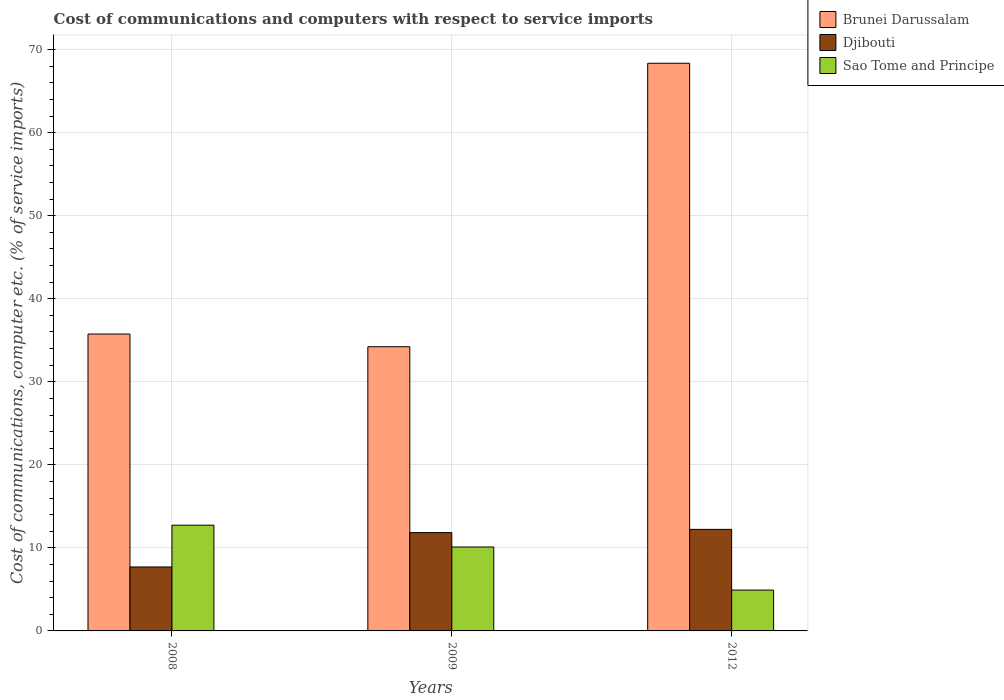How many different coloured bars are there?
Ensure brevity in your answer.  3. Are the number of bars per tick equal to the number of legend labels?
Give a very brief answer. Yes. How many bars are there on the 3rd tick from the left?
Your answer should be compact. 3. How many bars are there on the 3rd tick from the right?
Offer a very short reply. 3. What is the label of the 1st group of bars from the left?
Offer a terse response. 2008. In how many cases, is the number of bars for a given year not equal to the number of legend labels?
Give a very brief answer. 0. What is the cost of communications and computers in Djibouti in 2008?
Give a very brief answer. 7.7. Across all years, what is the maximum cost of communications and computers in Djibouti?
Your response must be concise. 12.23. Across all years, what is the minimum cost of communications and computers in Djibouti?
Offer a terse response. 7.7. In which year was the cost of communications and computers in Sao Tome and Principe maximum?
Provide a succinct answer. 2008. What is the total cost of communications and computers in Djibouti in the graph?
Keep it short and to the point. 31.77. What is the difference between the cost of communications and computers in Brunei Darussalam in 2009 and that in 2012?
Your answer should be very brief. -34.14. What is the difference between the cost of communications and computers in Sao Tome and Principe in 2009 and the cost of communications and computers in Brunei Darussalam in 2012?
Provide a short and direct response. -58.26. What is the average cost of communications and computers in Sao Tome and Principe per year?
Ensure brevity in your answer.  9.25. In the year 2009, what is the difference between the cost of communications and computers in Sao Tome and Principe and cost of communications and computers in Brunei Darussalam?
Make the answer very short. -24.12. In how many years, is the cost of communications and computers in Sao Tome and Principe greater than 12 %?
Your answer should be very brief. 1. What is the ratio of the cost of communications and computers in Djibouti in 2008 to that in 2009?
Your answer should be compact. 0.65. Is the difference between the cost of communications and computers in Sao Tome and Principe in 2009 and 2012 greater than the difference between the cost of communications and computers in Brunei Darussalam in 2009 and 2012?
Your answer should be compact. Yes. What is the difference between the highest and the second highest cost of communications and computers in Djibouti?
Offer a very short reply. 0.39. What is the difference between the highest and the lowest cost of communications and computers in Brunei Darussalam?
Your answer should be compact. 34.14. What does the 2nd bar from the left in 2009 represents?
Ensure brevity in your answer.  Djibouti. What does the 2nd bar from the right in 2012 represents?
Provide a short and direct response. Djibouti. Is it the case that in every year, the sum of the cost of communications and computers in Sao Tome and Principe and cost of communications and computers in Brunei Darussalam is greater than the cost of communications and computers in Djibouti?
Make the answer very short. Yes. How many bars are there?
Provide a succinct answer. 9. How many years are there in the graph?
Give a very brief answer. 3. Does the graph contain grids?
Make the answer very short. Yes. Where does the legend appear in the graph?
Offer a terse response. Top right. How are the legend labels stacked?
Make the answer very short. Vertical. What is the title of the graph?
Provide a short and direct response. Cost of communications and computers with respect to service imports. What is the label or title of the Y-axis?
Keep it short and to the point. Cost of communications, computer etc. (% of service imports). What is the Cost of communications, computer etc. (% of service imports) in Brunei Darussalam in 2008?
Make the answer very short. 35.76. What is the Cost of communications, computer etc. (% of service imports) in Djibouti in 2008?
Offer a terse response. 7.7. What is the Cost of communications, computer etc. (% of service imports) in Sao Tome and Principe in 2008?
Provide a short and direct response. 12.73. What is the Cost of communications, computer etc. (% of service imports) of Brunei Darussalam in 2009?
Your answer should be very brief. 34.22. What is the Cost of communications, computer etc. (% of service imports) in Djibouti in 2009?
Offer a very short reply. 11.84. What is the Cost of communications, computer etc. (% of service imports) of Sao Tome and Principe in 2009?
Your answer should be very brief. 10.11. What is the Cost of communications, computer etc. (% of service imports) of Brunei Darussalam in 2012?
Provide a succinct answer. 68.36. What is the Cost of communications, computer etc. (% of service imports) in Djibouti in 2012?
Offer a terse response. 12.23. What is the Cost of communications, computer etc. (% of service imports) of Sao Tome and Principe in 2012?
Your answer should be very brief. 4.92. Across all years, what is the maximum Cost of communications, computer etc. (% of service imports) of Brunei Darussalam?
Offer a terse response. 68.36. Across all years, what is the maximum Cost of communications, computer etc. (% of service imports) of Djibouti?
Provide a succinct answer. 12.23. Across all years, what is the maximum Cost of communications, computer etc. (% of service imports) of Sao Tome and Principe?
Ensure brevity in your answer.  12.73. Across all years, what is the minimum Cost of communications, computer etc. (% of service imports) of Brunei Darussalam?
Your answer should be very brief. 34.22. Across all years, what is the minimum Cost of communications, computer etc. (% of service imports) of Djibouti?
Your answer should be compact. 7.7. Across all years, what is the minimum Cost of communications, computer etc. (% of service imports) in Sao Tome and Principe?
Your response must be concise. 4.92. What is the total Cost of communications, computer etc. (% of service imports) of Brunei Darussalam in the graph?
Your answer should be compact. 138.34. What is the total Cost of communications, computer etc. (% of service imports) in Djibouti in the graph?
Offer a terse response. 31.77. What is the total Cost of communications, computer etc. (% of service imports) of Sao Tome and Principe in the graph?
Offer a very short reply. 27.76. What is the difference between the Cost of communications, computer etc. (% of service imports) of Brunei Darussalam in 2008 and that in 2009?
Your answer should be very brief. 1.53. What is the difference between the Cost of communications, computer etc. (% of service imports) in Djibouti in 2008 and that in 2009?
Your answer should be compact. -4.14. What is the difference between the Cost of communications, computer etc. (% of service imports) of Sao Tome and Principe in 2008 and that in 2009?
Make the answer very short. 2.63. What is the difference between the Cost of communications, computer etc. (% of service imports) in Brunei Darussalam in 2008 and that in 2012?
Offer a very short reply. -32.61. What is the difference between the Cost of communications, computer etc. (% of service imports) of Djibouti in 2008 and that in 2012?
Offer a very short reply. -4.53. What is the difference between the Cost of communications, computer etc. (% of service imports) of Sao Tome and Principe in 2008 and that in 2012?
Your answer should be very brief. 7.81. What is the difference between the Cost of communications, computer etc. (% of service imports) of Brunei Darussalam in 2009 and that in 2012?
Your answer should be very brief. -34.14. What is the difference between the Cost of communications, computer etc. (% of service imports) in Djibouti in 2009 and that in 2012?
Your response must be concise. -0.39. What is the difference between the Cost of communications, computer etc. (% of service imports) of Sao Tome and Principe in 2009 and that in 2012?
Your answer should be compact. 5.19. What is the difference between the Cost of communications, computer etc. (% of service imports) of Brunei Darussalam in 2008 and the Cost of communications, computer etc. (% of service imports) of Djibouti in 2009?
Provide a succinct answer. 23.92. What is the difference between the Cost of communications, computer etc. (% of service imports) of Brunei Darussalam in 2008 and the Cost of communications, computer etc. (% of service imports) of Sao Tome and Principe in 2009?
Provide a short and direct response. 25.65. What is the difference between the Cost of communications, computer etc. (% of service imports) in Djibouti in 2008 and the Cost of communications, computer etc. (% of service imports) in Sao Tome and Principe in 2009?
Ensure brevity in your answer.  -2.4. What is the difference between the Cost of communications, computer etc. (% of service imports) in Brunei Darussalam in 2008 and the Cost of communications, computer etc. (% of service imports) in Djibouti in 2012?
Offer a terse response. 23.53. What is the difference between the Cost of communications, computer etc. (% of service imports) in Brunei Darussalam in 2008 and the Cost of communications, computer etc. (% of service imports) in Sao Tome and Principe in 2012?
Give a very brief answer. 30.84. What is the difference between the Cost of communications, computer etc. (% of service imports) in Djibouti in 2008 and the Cost of communications, computer etc. (% of service imports) in Sao Tome and Principe in 2012?
Offer a very short reply. 2.78. What is the difference between the Cost of communications, computer etc. (% of service imports) in Brunei Darussalam in 2009 and the Cost of communications, computer etc. (% of service imports) in Djibouti in 2012?
Keep it short and to the point. 22. What is the difference between the Cost of communications, computer etc. (% of service imports) of Brunei Darussalam in 2009 and the Cost of communications, computer etc. (% of service imports) of Sao Tome and Principe in 2012?
Make the answer very short. 29.31. What is the difference between the Cost of communications, computer etc. (% of service imports) in Djibouti in 2009 and the Cost of communications, computer etc. (% of service imports) in Sao Tome and Principe in 2012?
Provide a short and direct response. 6.92. What is the average Cost of communications, computer etc. (% of service imports) of Brunei Darussalam per year?
Provide a succinct answer. 46.11. What is the average Cost of communications, computer etc. (% of service imports) of Djibouti per year?
Provide a short and direct response. 10.59. What is the average Cost of communications, computer etc. (% of service imports) in Sao Tome and Principe per year?
Make the answer very short. 9.25. In the year 2008, what is the difference between the Cost of communications, computer etc. (% of service imports) in Brunei Darussalam and Cost of communications, computer etc. (% of service imports) in Djibouti?
Offer a very short reply. 28.05. In the year 2008, what is the difference between the Cost of communications, computer etc. (% of service imports) in Brunei Darussalam and Cost of communications, computer etc. (% of service imports) in Sao Tome and Principe?
Offer a very short reply. 23.02. In the year 2008, what is the difference between the Cost of communications, computer etc. (% of service imports) in Djibouti and Cost of communications, computer etc. (% of service imports) in Sao Tome and Principe?
Provide a succinct answer. -5.03. In the year 2009, what is the difference between the Cost of communications, computer etc. (% of service imports) in Brunei Darussalam and Cost of communications, computer etc. (% of service imports) in Djibouti?
Provide a succinct answer. 22.39. In the year 2009, what is the difference between the Cost of communications, computer etc. (% of service imports) in Brunei Darussalam and Cost of communications, computer etc. (% of service imports) in Sao Tome and Principe?
Provide a short and direct response. 24.12. In the year 2009, what is the difference between the Cost of communications, computer etc. (% of service imports) in Djibouti and Cost of communications, computer etc. (% of service imports) in Sao Tome and Principe?
Your response must be concise. 1.73. In the year 2012, what is the difference between the Cost of communications, computer etc. (% of service imports) of Brunei Darussalam and Cost of communications, computer etc. (% of service imports) of Djibouti?
Keep it short and to the point. 56.13. In the year 2012, what is the difference between the Cost of communications, computer etc. (% of service imports) of Brunei Darussalam and Cost of communications, computer etc. (% of service imports) of Sao Tome and Principe?
Keep it short and to the point. 63.44. In the year 2012, what is the difference between the Cost of communications, computer etc. (% of service imports) in Djibouti and Cost of communications, computer etc. (% of service imports) in Sao Tome and Principe?
Your answer should be compact. 7.31. What is the ratio of the Cost of communications, computer etc. (% of service imports) in Brunei Darussalam in 2008 to that in 2009?
Offer a terse response. 1.04. What is the ratio of the Cost of communications, computer etc. (% of service imports) of Djibouti in 2008 to that in 2009?
Provide a short and direct response. 0.65. What is the ratio of the Cost of communications, computer etc. (% of service imports) in Sao Tome and Principe in 2008 to that in 2009?
Provide a succinct answer. 1.26. What is the ratio of the Cost of communications, computer etc. (% of service imports) of Brunei Darussalam in 2008 to that in 2012?
Ensure brevity in your answer.  0.52. What is the ratio of the Cost of communications, computer etc. (% of service imports) in Djibouti in 2008 to that in 2012?
Your response must be concise. 0.63. What is the ratio of the Cost of communications, computer etc. (% of service imports) in Sao Tome and Principe in 2008 to that in 2012?
Offer a very short reply. 2.59. What is the ratio of the Cost of communications, computer etc. (% of service imports) in Brunei Darussalam in 2009 to that in 2012?
Make the answer very short. 0.5. What is the ratio of the Cost of communications, computer etc. (% of service imports) in Djibouti in 2009 to that in 2012?
Your answer should be very brief. 0.97. What is the ratio of the Cost of communications, computer etc. (% of service imports) of Sao Tome and Principe in 2009 to that in 2012?
Provide a succinct answer. 2.05. What is the difference between the highest and the second highest Cost of communications, computer etc. (% of service imports) of Brunei Darussalam?
Ensure brevity in your answer.  32.61. What is the difference between the highest and the second highest Cost of communications, computer etc. (% of service imports) of Djibouti?
Ensure brevity in your answer.  0.39. What is the difference between the highest and the second highest Cost of communications, computer etc. (% of service imports) in Sao Tome and Principe?
Keep it short and to the point. 2.63. What is the difference between the highest and the lowest Cost of communications, computer etc. (% of service imports) of Brunei Darussalam?
Ensure brevity in your answer.  34.14. What is the difference between the highest and the lowest Cost of communications, computer etc. (% of service imports) in Djibouti?
Your response must be concise. 4.53. What is the difference between the highest and the lowest Cost of communications, computer etc. (% of service imports) of Sao Tome and Principe?
Provide a succinct answer. 7.81. 